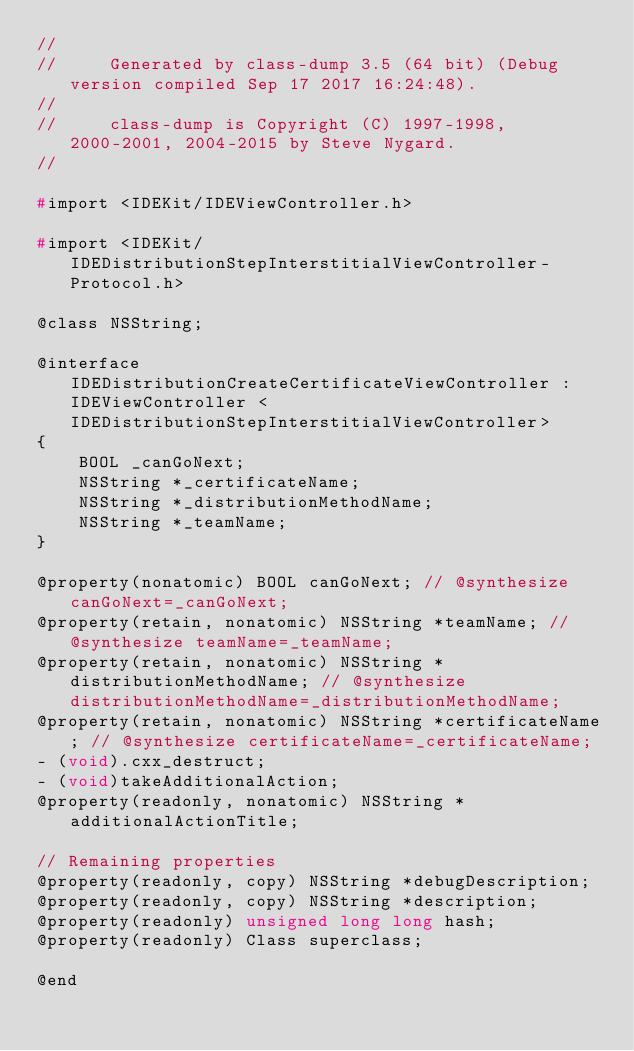<code> <loc_0><loc_0><loc_500><loc_500><_C_>//
//     Generated by class-dump 3.5 (64 bit) (Debug version compiled Sep 17 2017 16:24:48).
//
//     class-dump is Copyright (C) 1997-1998, 2000-2001, 2004-2015 by Steve Nygard.
//

#import <IDEKit/IDEViewController.h>

#import <IDEKit/IDEDistributionStepInterstitialViewController-Protocol.h>

@class NSString;

@interface IDEDistributionCreateCertificateViewController : IDEViewController <IDEDistributionStepInterstitialViewController>
{
    BOOL _canGoNext;
    NSString *_certificateName;
    NSString *_distributionMethodName;
    NSString *_teamName;
}

@property(nonatomic) BOOL canGoNext; // @synthesize canGoNext=_canGoNext;
@property(retain, nonatomic) NSString *teamName; // @synthesize teamName=_teamName;
@property(retain, nonatomic) NSString *distributionMethodName; // @synthesize distributionMethodName=_distributionMethodName;
@property(retain, nonatomic) NSString *certificateName; // @synthesize certificateName=_certificateName;
- (void).cxx_destruct;
- (void)takeAdditionalAction;
@property(readonly, nonatomic) NSString *additionalActionTitle;

// Remaining properties
@property(readonly, copy) NSString *debugDescription;
@property(readonly, copy) NSString *description;
@property(readonly) unsigned long long hash;
@property(readonly) Class superclass;

@end

</code> 